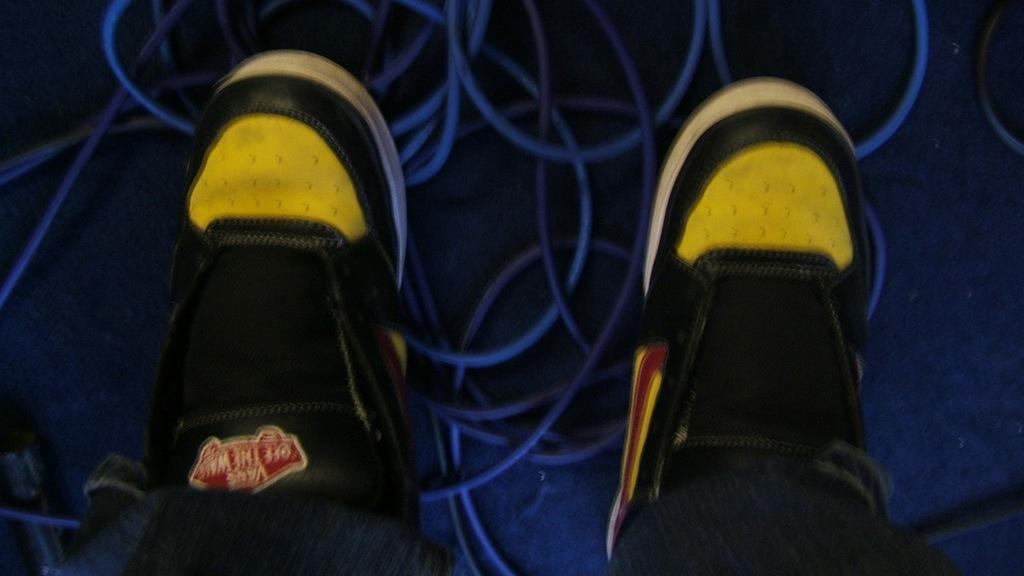What objects are present in the image? There are two shoes in the image. What colors are the shoes? The shoes are yellow and black in color. What else can be seen on the floor in the image? There are wires placed on the floor in the image. What type of art can be seen hanging on the wall in the image? There is no mention of a wall or any art in the image; it only features two shoes and wires on the floor. 